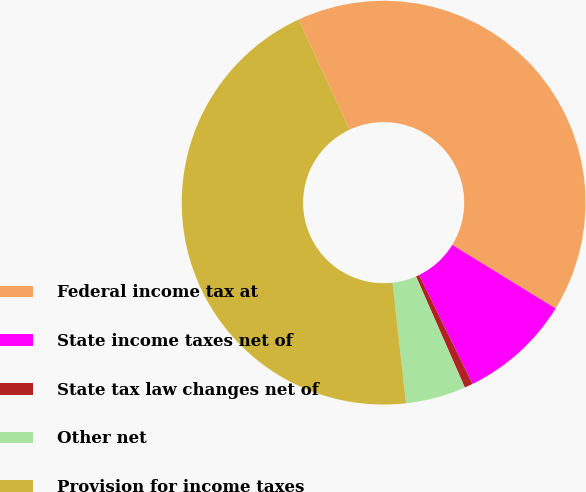Convert chart to OTSL. <chart><loc_0><loc_0><loc_500><loc_500><pie_chart><fcel>Federal income tax at<fcel>State income taxes net of<fcel>State tax law changes net of<fcel>Other net<fcel>Provision for income taxes<nl><fcel>40.7%<fcel>8.97%<fcel>0.67%<fcel>4.82%<fcel>44.85%<nl></chart> 